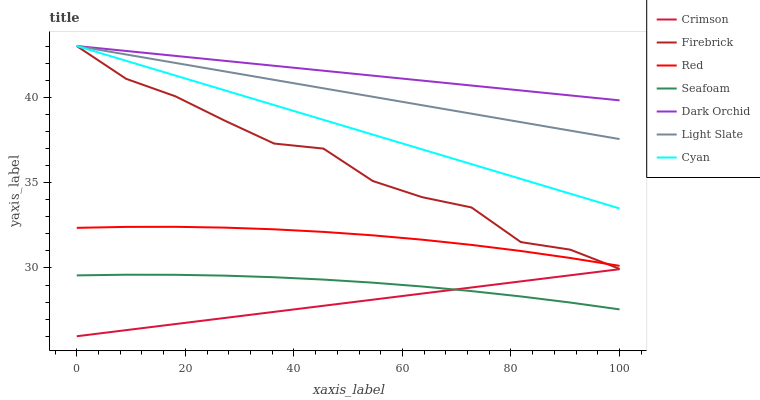Does Crimson have the minimum area under the curve?
Answer yes or no. Yes. Does Dark Orchid have the maximum area under the curve?
Answer yes or no. Yes. Does Firebrick have the minimum area under the curve?
Answer yes or no. No. Does Firebrick have the maximum area under the curve?
Answer yes or no. No. Is Light Slate the smoothest?
Answer yes or no. Yes. Is Firebrick the roughest?
Answer yes or no. Yes. Is Seafoam the smoothest?
Answer yes or no. No. Is Seafoam the roughest?
Answer yes or no. No. Does Firebrick have the lowest value?
Answer yes or no. No. Does Cyan have the highest value?
Answer yes or no. Yes. Does Seafoam have the highest value?
Answer yes or no. No. Is Red less than Cyan?
Answer yes or no. Yes. Is Light Slate greater than Red?
Answer yes or no. Yes. Does Dark Orchid intersect Cyan?
Answer yes or no. Yes. Is Dark Orchid less than Cyan?
Answer yes or no. No. Is Dark Orchid greater than Cyan?
Answer yes or no. No. Does Red intersect Cyan?
Answer yes or no. No. 